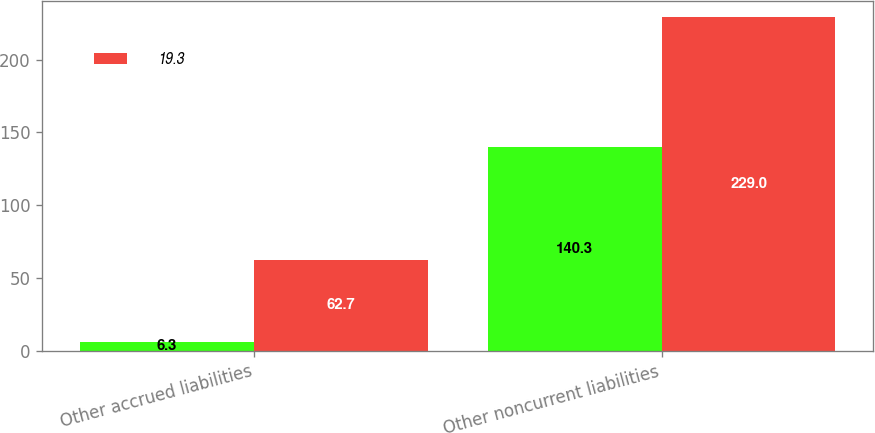Convert chart to OTSL. <chart><loc_0><loc_0><loc_500><loc_500><stacked_bar_chart><ecel><fcel>Other accrued liabilities<fcel>Other noncurrent liabilities<nl><fcel>nan<fcel>6.3<fcel>140.3<nl><fcel>19.3<fcel>62.7<fcel>229<nl></chart> 